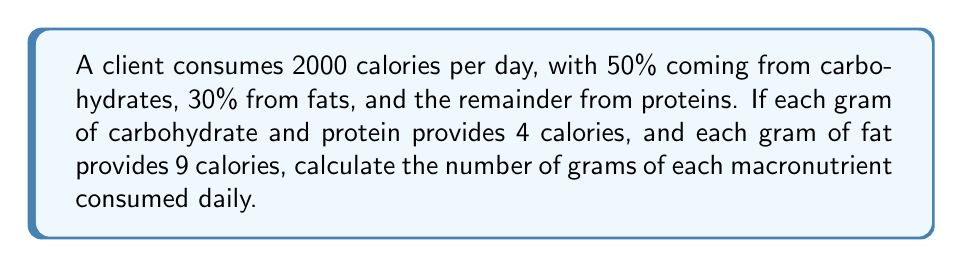Provide a solution to this math problem. 1. Calculate calories from each macronutrient:
   Carbohydrates: $0.50 \times 2000 = 1000$ calories
   Fats: $0.30 \times 2000 = 600$ calories
   Proteins: $0.20 \times 2000 = 400$ calories (remainder)

2. Convert calories to grams:
   Carbohydrates: $\frac{1000 \text{ calories}}{4 \text{ calories/g}} = 250$ g
   Fats: $\frac{600 \text{ calories}}{9 \text{ calories/g}} = 66.67$ g
   Proteins: $\frac{400 \text{ calories}}{4 \text{ calories/g}} = 100$ g

3. Round fat grams to nearest whole number: 67 g

Therefore, the client consumes 250 g of carbohydrates, 67 g of fats, and 100 g of proteins daily.
Answer: 250 g carbohydrates, 67 g fats, 100 g proteins 